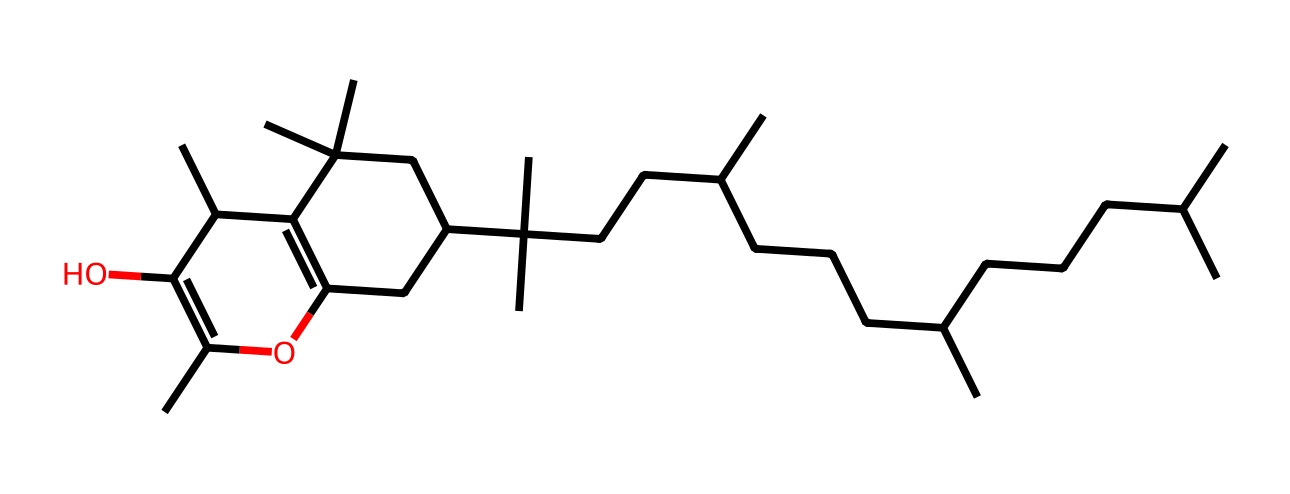What is the molecular formula of Vitamin E? The molecular formula can be derived from counting the carbon, hydrogen, and oxygen atoms in the structure. In this molecule, there are a total of 29 carbon atoms, 50 hydrogen atoms, and 2 oxygen atoms. This gives the molecular formula C29H50O2.
Answer: C29H50O2 How many double bonds are present in the structure of Vitamin E? By examining the structure, we identify the regions where carbon-carbon double bonds are present. There are two double bonds in this structure, which can be observed where the carbon atoms are connected by double lines.
Answer: 2 What type of vitamin is represented by this structural formula? This chemical structure corresponds to tocopherol, commonly known as Vitamin E, which is recognized as a fat-soluble vitamin.
Answer: fat-soluble What functional groups are present in Vitamin E? The chemical structure contains hydroxyl groups (-OH) as part of the catechol structure, which are functional groups that play a crucial role in its antioxidant properties.
Answer: hydroxyl groups What is the role of Vitamin E in wood oils? Vitamin E acts as an antioxidant in wood oils, helping to protect the oils from oxidative degradation and prolonging their shelf life and effectiveness.
Answer: antioxidant How does the structure of Vitamin E contribute to its antioxidant properties? The presence of the hydroxyl groups in the structure allows Vitamin E to donate hydrogen atoms to free radicals, thereby neutralizing them and preventing oxidative damage.
Answer: hydrogen donation Which part of Vitamin E structure is responsible for its antioxidant function? The hydroxyl group is the part of the structure that enables Vitamin E to act as an antioxidant, as it can interact with and neutralize free radicals.
Answer: hydroxyl group 